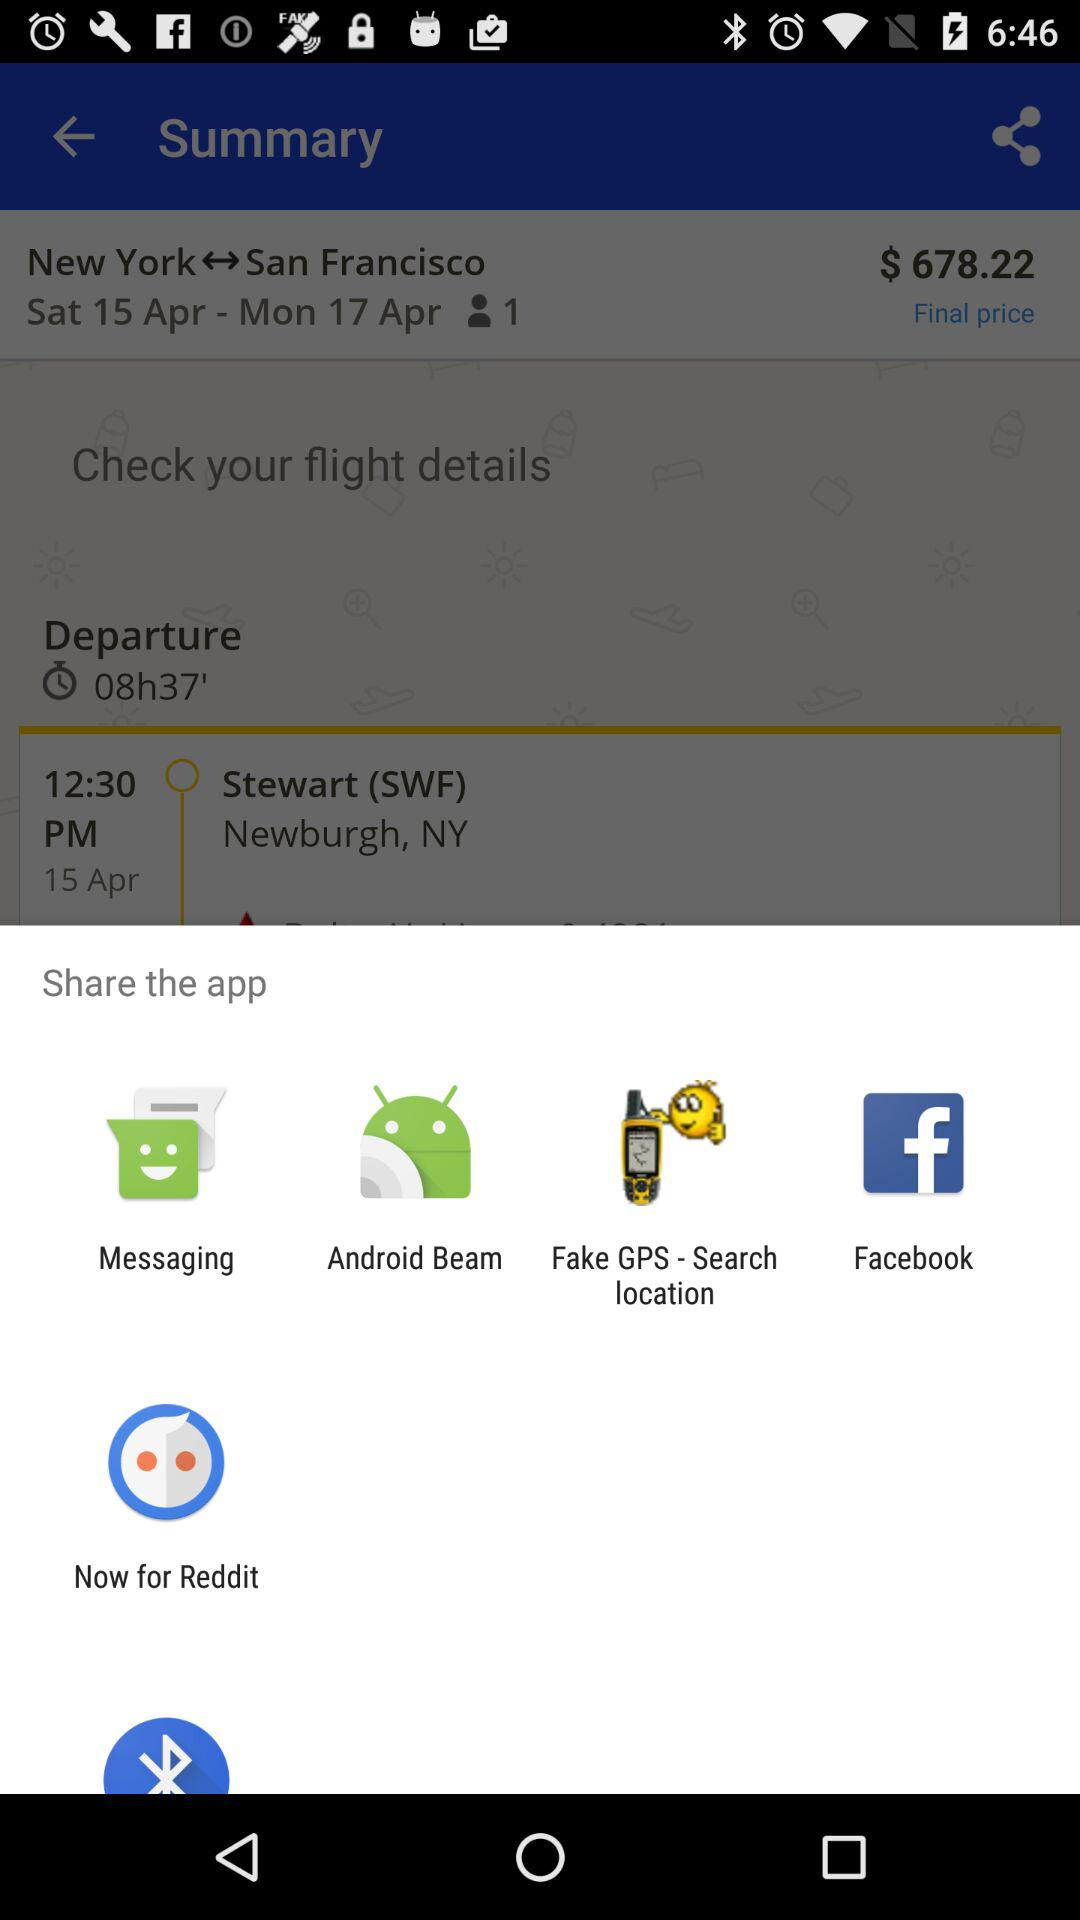What is the final price of the journey? The final price of the journey is $678.22. 